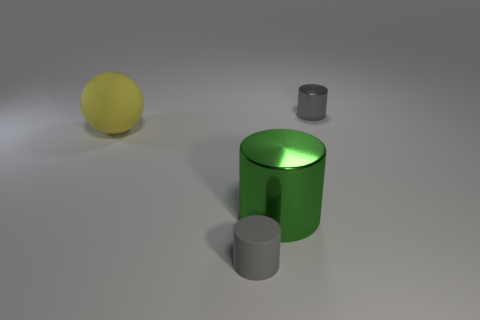There is a gray thing that is the same size as the gray rubber cylinder; what material is it?
Ensure brevity in your answer.  Metal. What number of things are behind the large metallic cylinder on the right side of the small object that is in front of the big matte thing?
Offer a terse response. 2. Does the rubber cylinder have the same size as the gray object that is behind the big yellow object?
Your answer should be compact. Yes. How many large green matte objects are there?
Give a very brief answer. 0. There is a gray thing that is behind the tiny matte cylinder; does it have the same size as the gray cylinder that is in front of the yellow thing?
Make the answer very short. Yes. There is another tiny thing that is the same shape as the small metallic thing; what is its color?
Offer a very short reply. Gray. Is the tiny matte object the same shape as the gray metal object?
Ensure brevity in your answer.  Yes. The green object that is the same shape as the gray metal thing is what size?
Make the answer very short. Large. How many green objects are made of the same material as the big yellow sphere?
Keep it short and to the point. 0. How many things are either large gray rubber objects or large yellow matte balls?
Your answer should be very brief. 1. 